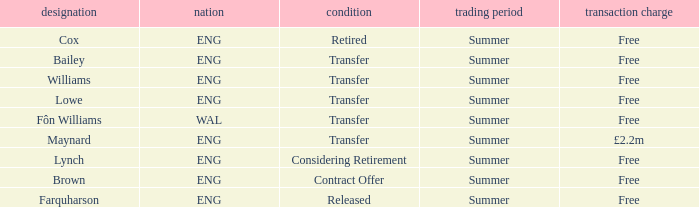What is the transfer window with a status of transfer from the country of Wal? Summer. 